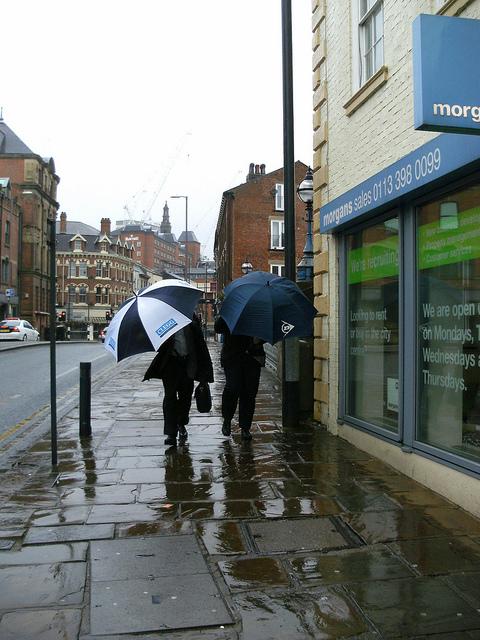Are the umbrellas talking to one another?
Write a very short answer. No. What is the weather?
Concise answer only. Rainy. Is there people in the crosswalk?
Be succinct. No. Is there traffic?
Be succinct. No. Are the people walking in the same direction?
Keep it brief. Yes. Is this photo filtered?
Quick response, please. No. 